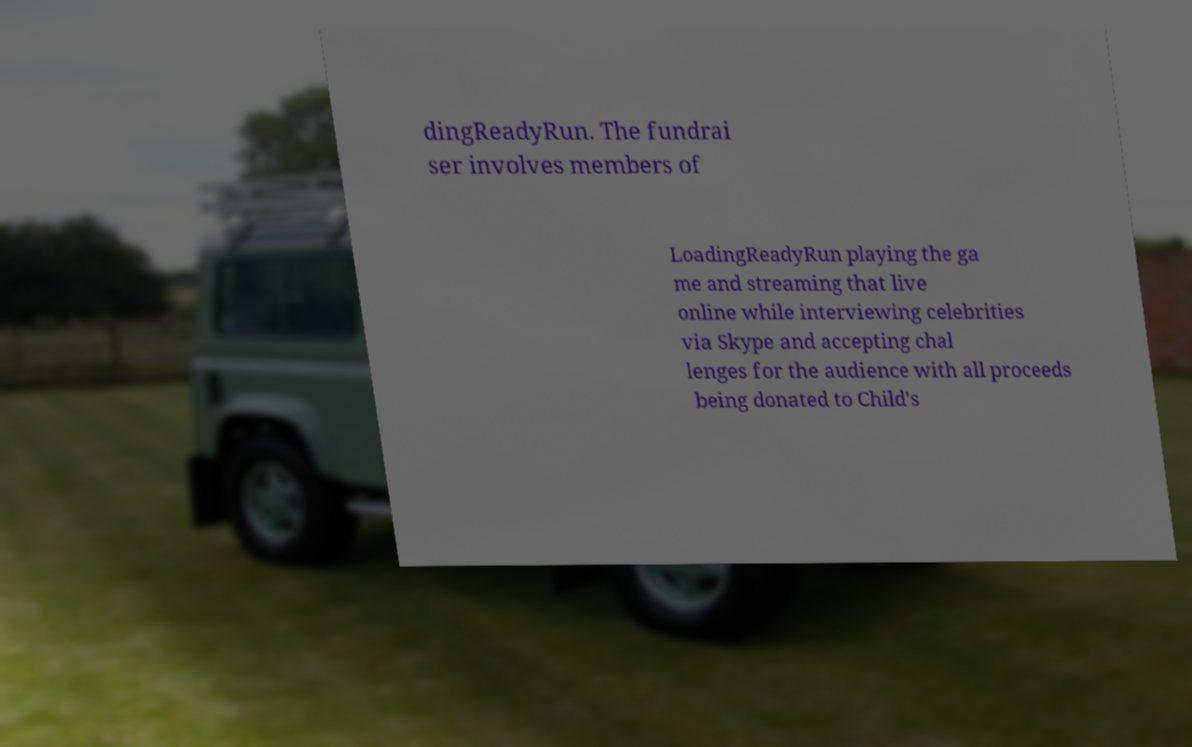Could you extract and type out the text from this image? dingReadyRun. The fundrai ser involves members of LoadingReadyRun playing the ga me and streaming that live online while interviewing celebrities via Skype and accepting chal lenges for the audience with all proceeds being donated to Child's 